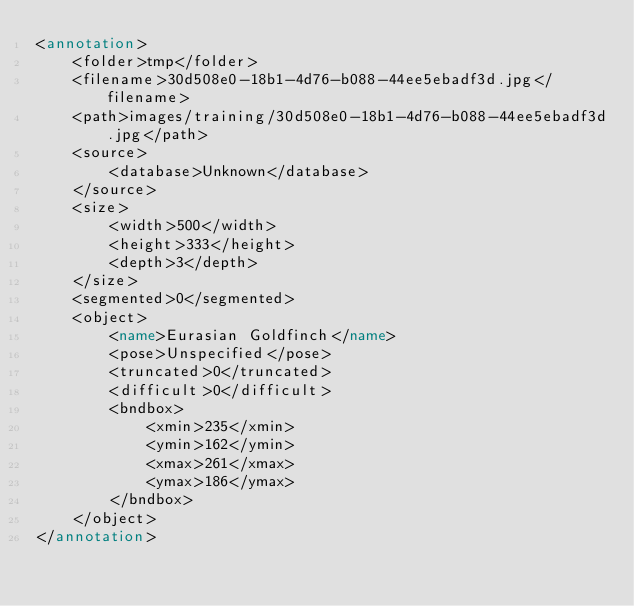<code> <loc_0><loc_0><loc_500><loc_500><_XML_><annotation>
	<folder>tmp</folder>
	<filename>30d508e0-18b1-4d76-b088-44ee5ebadf3d.jpg</filename>
	<path>images/training/30d508e0-18b1-4d76-b088-44ee5ebadf3d.jpg</path>
	<source>
		<database>Unknown</database>
	</source>
	<size>
		<width>500</width>
		<height>333</height>
		<depth>3</depth>
	</size>
	<segmented>0</segmented>
	<object>
		<name>Eurasian Goldfinch</name>
		<pose>Unspecified</pose>
		<truncated>0</truncated>
		<difficult>0</difficult>
		<bndbox>
			<xmin>235</xmin>
			<ymin>162</ymin>
			<xmax>261</xmax>
			<ymax>186</ymax>
		</bndbox>
	</object>
</annotation>
</code> 